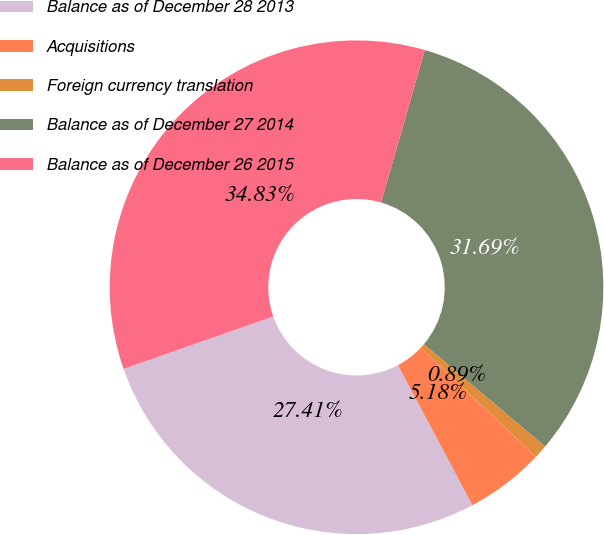Convert chart to OTSL. <chart><loc_0><loc_0><loc_500><loc_500><pie_chart><fcel>Balance as of December 28 2013<fcel>Acquisitions<fcel>Foreign currency translation<fcel>Balance as of December 27 2014<fcel>Balance as of December 26 2015<nl><fcel>27.41%<fcel>5.18%<fcel>0.89%<fcel>31.69%<fcel>34.83%<nl></chart> 